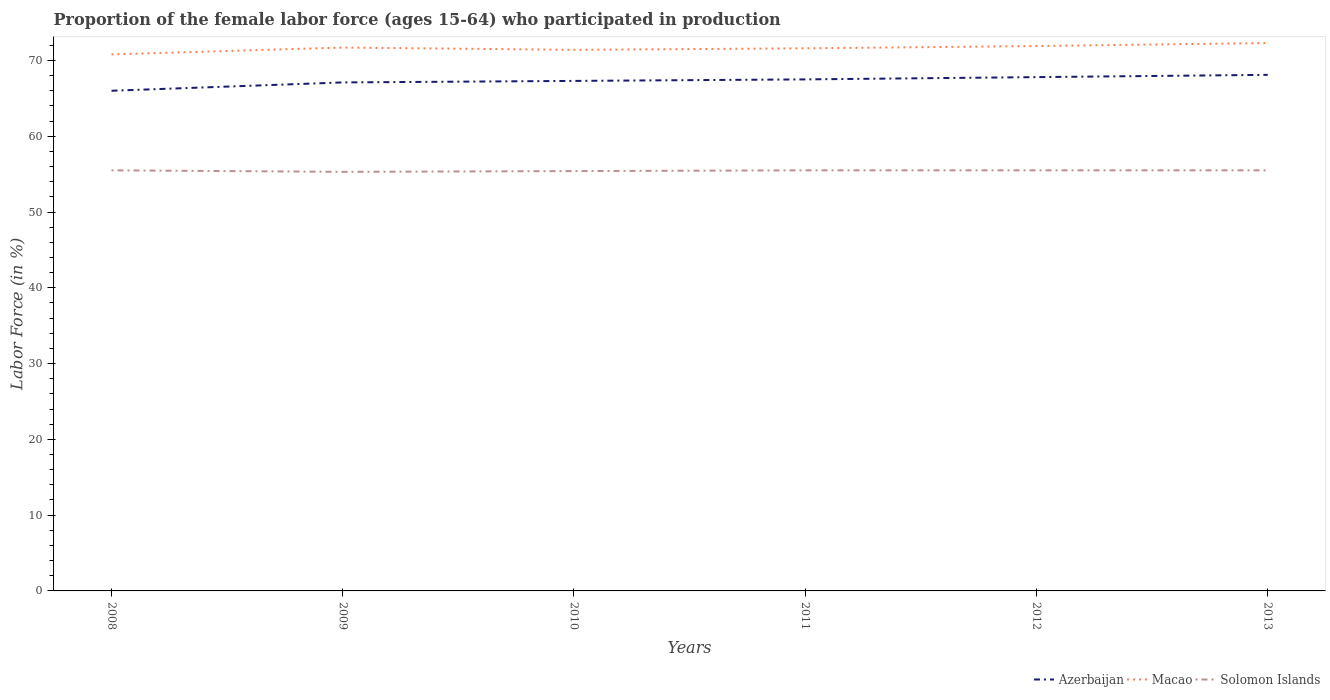How many different coloured lines are there?
Ensure brevity in your answer.  3. Across all years, what is the maximum proportion of the female labor force who participated in production in Solomon Islands?
Your response must be concise. 55.3. In which year was the proportion of the female labor force who participated in production in Azerbaijan maximum?
Your answer should be very brief. 2008. What is the total proportion of the female labor force who participated in production in Azerbaijan in the graph?
Your response must be concise. -0.7. What is the difference between the highest and the second highest proportion of the female labor force who participated in production in Solomon Islands?
Make the answer very short. 0.2. Is the proportion of the female labor force who participated in production in Solomon Islands strictly greater than the proportion of the female labor force who participated in production in Macao over the years?
Offer a very short reply. Yes. How many lines are there?
Your answer should be very brief. 3. How many years are there in the graph?
Offer a very short reply. 6. What is the difference between two consecutive major ticks on the Y-axis?
Offer a terse response. 10. Are the values on the major ticks of Y-axis written in scientific E-notation?
Your answer should be very brief. No. Does the graph contain any zero values?
Your answer should be very brief. No. Does the graph contain grids?
Offer a very short reply. No. How many legend labels are there?
Ensure brevity in your answer.  3. What is the title of the graph?
Your response must be concise. Proportion of the female labor force (ages 15-64) who participated in production. What is the label or title of the X-axis?
Offer a terse response. Years. What is the Labor Force (in %) in Azerbaijan in 2008?
Offer a very short reply. 66. What is the Labor Force (in %) of Macao in 2008?
Your answer should be very brief. 70.8. What is the Labor Force (in %) of Solomon Islands in 2008?
Offer a very short reply. 55.5. What is the Labor Force (in %) of Azerbaijan in 2009?
Provide a succinct answer. 67.1. What is the Labor Force (in %) of Macao in 2009?
Keep it short and to the point. 71.7. What is the Labor Force (in %) of Solomon Islands in 2009?
Provide a succinct answer. 55.3. What is the Labor Force (in %) of Azerbaijan in 2010?
Provide a short and direct response. 67.3. What is the Labor Force (in %) in Macao in 2010?
Offer a terse response. 71.4. What is the Labor Force (in %) in Solomon Islands in 2010?
Your answer should be compact. 55.4. What is the Labor Force (in %) of Azerbaijan in 2011?
Keep it short and to the point. 67.5. What is the Labor Force (in %) in Macao in 2011?
Your answer should be very brief. 71.6. What is the Labor Force (in %) in Solomon Islands in 2011?
Provide a succinct answer. 55.5. What is the Labor Force (in %) of Azerbaijan in 2012?
Give a very brief answer. 67.8. What is the Labor Force (in %) of Macao in 2012?
Your answer should be very brief. 71.9. What is the Labor Force (in %) of Solomon Islands in 2012?
Offer a terse response. 55.5. What is the Labor Force (in %) in Azerbaijan in 2013?
Provide a short and direct response. 68.1. What is the Labor Force (in %) in Macao in 2013?
Your answer should be compact. 72.3. What is the Labor Force (in %) of Solomon Islands in 2013?
Ensure brevity in your answer.  55.5. Across all years, what is the maximum Labor Force (in %) of Azerbaijan?
Give a very brief answer. 68.1. Across all years, what is the maximum Labor Force (in %) in Macao?
Give a very brief answer. 72.3. Across all years, what is the maximum Labor Force (in %) of Solomon Islands?
Ensure brevity in your answer.  55.5. Across all years, what is the minimum Labor Force (in %) in Azerbaijan?
Make the answer very short. 66. Across all years, what is the minimum Labor Force (in %) of Macao?
Keep it short and to the point. 70.8. Across all years, what is the minimum Labor Force (in %) of Solomon Islands?
Offer a very short reply. 55.3. What is the total Labor Force (in %) of Azerbaijan in the graph?
Offer a terse response. 403.8. What is the total Labor Force (in %) of Macao in the graph?
Give a very brief answer. 429.7. What is the total Labor Force (in %) in Solomon Islands in the graph?
Ensure brevity in your answer.  332.7. What is the difference between the Labor Force (in %) in Azerbaijan in 2008 and that in 2009?
Provide a succinct answer. -1.1. What is the difference between the Labor Force (in %) in Macao in 2008 and that in 2009?
Provide a short and direct response. -0.9. What is the difference between the Labor Force (in %) in Azerbaijan in 2008 and that in 2011?
Give a very brief answer. -1.5. What is the difference between the Labor Force (in %) of Macao in 2008 and that in 2011?
Keep it short and to the point. -0.8. What is the difference between the Labor Force (in %) of Solomon Islands in 2008 and that in 2011?
Offer a very short reply. 0. What is the difference between the Labor Force (in %) in Macao in 2008 and that in 2012?
Your response must be concise. -1.1. What is the difference between the Labor Force (in %) of Solomon Islands in 2008 and that in 2012?
Your answer should be very brief. 0. What is the difference between the Labor Force (in %) in Azerbaijan in 2008 and that in 2013?
Offer a very short reply. -2.1. What is the difference between the Labor Force (in %) in Macao in 2008 and that in 2013?
Make the answer very short. -1.5. What is the difference between the Labor Force (in %) in Azerbaijan in 2009 and that in 2010?
Ensure brevity in your answer.  -0.2. What is the difference between the Labor Force (in %) of Macao in 2009 and that in 2010?
Provide a short and direct response. 0.3. What is the difference between the Labor Force (in %) in Azerbaijan in 2009 and that in 2011?
Offer a terse response. -0.4. What is the difference between the Labor Force (in %) of Azerbaijan in 2009 and that in 2012?
Provide a short and direct response. -0.7. What is the difference between the Labor Force (in %) in Azerbaijan in 2009 and that in 2013?
Your answer should be very brief. -1. What is the difference between the Labor Force (in %) in Macao in 2009 and that in 2013?
Your answer should be very brief. -0.6. What is the difference between the Labor Force (in %) in Solomon Islands in 2009 and that in 2013?
Provide a short and direct response. -0.2. What is the difference between the Labor Force (in %) in Macao in 2010 and that in 2011?
Your answer should be compact. -0.2. What is the difference between the Labor Force (in %) of Azerbaijan in 2010 and that in 2012?
Offer a terse response. -0.5. What is the difference between the Labor Force (in %) of Macao in 2010 and that in 2012?
Give a very brief answer. -0.5. What is the difference between the Labor Force (in %) of Solomon Islands in 2010 and that in 2013?
Your response must be concise. -0.1. What is the difference between the Labor Force (in %) of Macao in 2011 and that in 2012?
Your answer should be compact. -0.3. What is the difference between the Labor Force (in %) in Solomon Islands in 2011 and that in 2012?
Keep it short and to the point. 0. What is the difference between the Labor Force (in %) in Solomon Islands in 2011 and that in 2013?
Ensure brevity in your answer.  0. What is the difference between the Labor Force (in %) of Macao in 2012 and that in 2013?
Make the answer very short. -0.4. What is the difference between the Labor Force (in %) in Azerbaijan in 2008 and the Labor Force (in %) in Solomon Islands in 2011?
Make the answer very short. 10.5. What is the difference between the Labor Force (in %) of Macao in 2008 and the Labor Force (in %) of Solomon Islands in 2011?
Provide a succinct answer. 15.3. What is the difference between the Labor Force (in %) of Azerbaijan in 2008 and the Labor Force (in %) of Macao in 2012?
Provide a succinct answer. -5.9. What is the difference between the Labor Force (in %) in Macao in 2008 and the Labor Force (in %) in Solomon Islands in 2012?
Your answer should be very brief. 15.3. What is the difference between the Labor Force (in %) of Azerbaijan in 2008 and the Labor Force (in %) of Macao in 2013?
Give a very brief answer. -6.3. What is the difference between the Labor Force (in %) in Azerbaijan in 2009 and the Labor Force (in %) in Macao in 2010?
Ensure brevity in your answer.  -4.3. What is the difference between the Labor Force (in %) of Azerbaijan in 2009 and the Labor Force (in %) of Macao in 2011?
Ensure brevity in your answer.  -4.5. What is the difference between the Labor Force (in %) in Azerbaijan in 2009 and the Labor Force (in %) in Macao in 2012?
Make the answer very short. -4.8. What is the difference between the Labor Force (in %) of Azerbaijan in 2009 and the Labor Force (in %) of Solomon Islands in 2012?
Give a very brief answer. 11.6. What is the difference between the Labor Force (in %) of Azerbaijan in 2009 and the Labor Force (in %) of Macao in 2013?
Keep it short and to the point. -5.2. What is the difference between the Labor Force (in %) in Azerbaijan in 2010 and the Labor Force (in %) in Solomon Islands in 2011?
Offer a very short reply. 11.8. What is the difference between the Labor Force (in %) in Macao in 2010 and the Labor Force (in %) in Solomon Islands in 2011?
Keep it short and to the point. 15.9. What is the difference between the Labor Force (in %) of Azerbaijan in 2010 and the Labor Force (in %) of Solomon Islands in 2012?
Your answer should be very brief. 11.8. What is the difference between the Labor Force (in %) of Azerbaijan in 2011 and the Labor Force (in %) of Macao in 2012?
Make the answer very short. -4.4. What is the difference between the Labor Force (in %) of Macao in 2011 and the Labor Force (in %) of Solomon Islands in 2012?
Your answer should be compact. 16.1. What is the difference between the Labor Force (in %) in Azerbaijan in 2011 and the Labor Force (in %) in Macao in 2013?
Give a very brief answer. -4.8. What is the difference between the Labor Force (in %) in Azerbaijan in 2011 and the Labor Force (in %) in Solomon Islands in 2013?
Ensure brevity in your answer.  12. What is the difference between the Labor Force (in %) of Macao in 2011 and the Labor Force (in %) of Solomon Islands in 2013?
Your answer should be compact. 16.1. What is the difference between the Labor Force (in %) of Azerbaijan in 2012 and the Labor Force (in %) of Macao in 2013?
Your answer should be very brief. -4.5. What is the average Labor Force (in %) in Azerbaijan per year?
Your answer should be very brief. 67.3. What is the average Labor Force (in %) in Macao per year?
Offer a very short reply. 71.62. What is the average Labor Force (in %) of Solomon Islands per year?
Offer a very short reply. 55.45. In the year 2008, what is the difference between the Labor Force (in %) in Azerbaijan and Labor Force (in %) in Macao?
Provide a succinct answer. -4.8. In the year 2008, what is the difference between the Labor Force (in %) in Azerbaijan and Labor Force (in %) in Solomon Islands?
Keep it short and to the point. 10.5. In the year 2009, what is the difference between the Labor Force (in %) of Azerbaijan and Labor Force (in %) of Macao?
Give a very brief answer. -4.6. In the year 2009, what is the difference between the Labor Force (in %) in Azerbaijan and Labor Force (in %) in Solomon Islands?
Offer a very short reply. 11.8. In the year 2009, what is the difference between the Labor Force (in %) in Macao and Labor Force (in %) in Solomon Islands?
Make the answer very short. 16.4. In the year 2010, what is the difference between the Labor Force (in %) of Macao and Labor Force (in %) of Solomon Islands?
Your response must be concise. 16. In the year 2011, what is the difference between the Labor Force (in %) of Azerbaijan and Labor Force (in %) of Macao?
Offer a terse response. -4.1. In the year 2011, what is the difference between the Labor Force (in %) of Azerbaijan and Labor Force (in %) of Solomon Islands?
Provide a short and direct response. 12. In the year 2012, what is the difference between the Labor Force (in %) of Azerbaijan and Labor Force (in %) of Solomon Islands?
Your answer should be compact. 12.3. In the year 2012, what is the difference between the Labor Force (in %) in Macao and Labor Force (in %) in Solomon Islands?
Provide a short and direct response. 16.4. In the year 2013, what is the difference between the Labor Force (in %) in Azerbaijan and Labor Force (in %) in Macao?
Provide a succinct answer. -4.2. In the year 2013, what is the difference between the Labor Force (in %) of Macao and Labor Force (in %) of Solomon Islands?
Offer a terse response. 16.8. What is the ratio of the Labor Force (in %) in Azerbaijan in 2008 to that in 2009?
Offer a terse response. 0.98. What is the ratio of the Labor Force (in %) in Macao in 2008 to that in 2009?
Offer a terse response. 0.99. What is the ratio of the Labor Force (in %) in Solomon Islands in 2008 to that in 2009?
Your response must be concise. 1. What is the ratio of the Labor Force (in %) of Azerbaijan in 2008 to that in 2010?
Your response must be concise. 0.98. What is the ratio of the Labor Force (in %) of Azerbaijan in 2008 to that in 2011?
Offer a terse response. 0.98. What is the ratio of the Labor Force (in %) in Macao in 2008 to that in 2011?
Your answer should be compact. 0.99. What is the ratio of the Labor Force (in %) in Azerbaijan in 2008 to that in 2012?
Offer a very short reply. 0.97. What is the ratio of the Labor Force (in %) of Macao in 2008 to that in 2012?
Provide a short and direct response. 0.98. What is the ratio of the Labor Force (in %) in Solomon Islands in 2008 to that in 2012?
Keep it short and to the point. 1. What is the ratio of the Labor Force (in %) in Azerbaijan in 2008 to that in 2013?
Keep it short and to the point. 0.97. What is the ratio of the Labor Force (in %) of Macao in 2008 to that in 2013?
Ensure brevity in your answer.  0.98. What is the ratio of the Labor Force (in %) of Azerbaijan in 2009 to that in 2011?
Provide a succinct answer. 0.99. What is the ratio of the Labor Force (in %) in Macao in 2009 to that in 2011?
Offer a very short reply. 1. What is the ratio of the Labor Force (in %) of Solomon Islands in 2009 to that in 2011?
Make the answer very short. 1. What is the ratio of the Labor Force (in %) in Macao in 2009 to that in 2012?
Your answer should be very brief. 1. What is the ratio of the Labor Force (in %) in Solomon Islands in 2009 to that in 2012?
Offer a terse response. 1. What is the ratio of the Labor Force (in %) of Azerbaijan in 2010 to that in 2011?
Your response must be concise. 1. What is the ratio of the Labor Force (in %) in Macao in 2010 to that in 2011?
Keep it short and to the point. 1. What is the ratio of the Labor Force (in %) in Azerbaijan in 2010 to that in 2012?
Make the answer very short. 0.99. What is the ratio of the Labor Force (in %) in Macao in 2010 to that in 2012?
Offer a very short reply. 0.99. What is the ratio of the Labor Force (in %) in Solomon Islands in 2010 to that in 2012?
Ensure brevity in your answer.  1. What is the ratio of the Labor Force (in %) of Azerbaijan in 2010 to that in 2013?
Keep it short and to the point. 0.99. What is the ratio of the Labor Force (in %) of Macao in 2010 to that in 2013?
Provide a short and direct response. 0.99. What is the ratio of the Labor Force (in %) of Azerbaijan in 2011 to that in 2012?
Give a very brief answer. 1. What is the ratio of the Labor Force (in %) of Macao in 2011 to that in 2012?
Give a very brief answer. 1. What is the ratio of the Labor Force (in %) in Azerbaijan in 2011 to that in 2013?
Offer a very short reply. 0.99. What is the ratio of the Labor Force (in %) in Macao in 2011 to that in 2013?
Ensure brevity in your answer.  0.99. What is the ratio of the Labor Force (in %) of Solomon Islands in 2011 to that in 2013?
Make the answer very short. 1. What is the ratio of the Labor Force (in %) in Azerbaijan in 2012 to that in 2013?
Provide a succinct answer. 1. What is the difference between the highest and the second highest Labor Force (in %) of Azerbaijan?
Provide a succinct answer. 0.3. What is the difference between the highest and the second highest Labor Force (in %) in Solomon Islands?
Your answer should be very brief. 0. What is the difference between the highest and the lowest Labor Force (in %) of Macao?
Your answer should be very brief. 1.5. What is the difference between the highest and the lowest Labor Force (in %) of Solomon Islands?
Offer a very short reply. 0.2. 